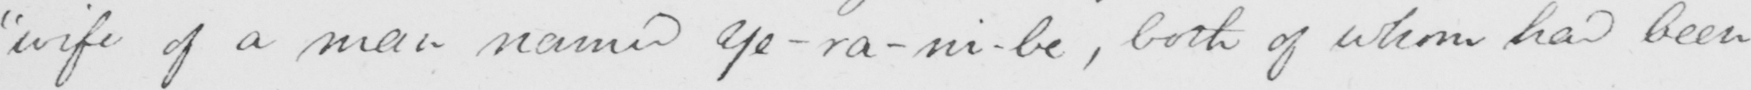Please transcribe the handwritten text in this image. "wife of a man named Ye-ra-ni-be , both of whom had been 